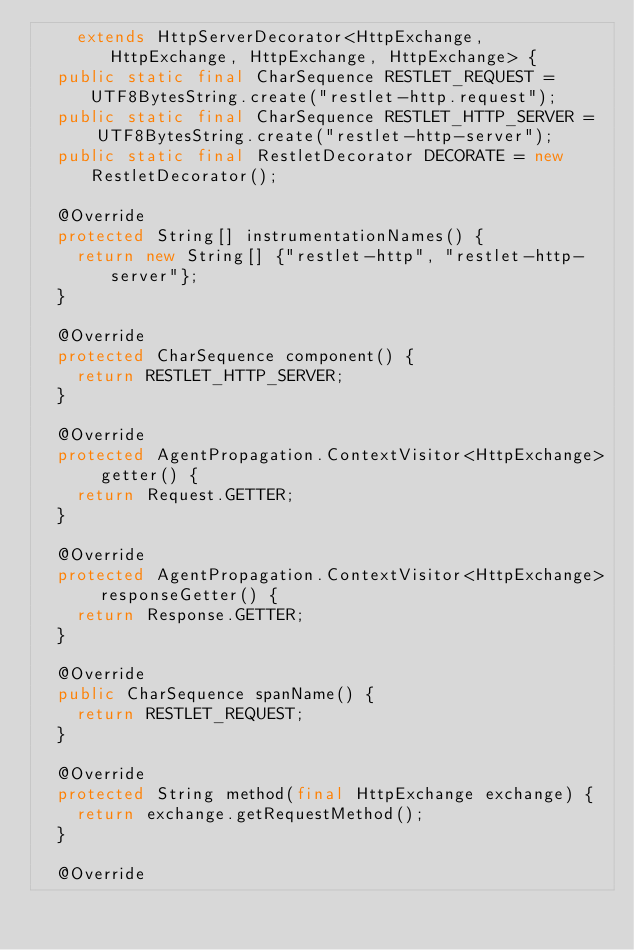Convert code to text. <code><loc_0><loc_0><loc_500><loc_500><_Java_>    extends HttpServerDecorator<HttpExchange, HttpExchange, HttpExchange, HttpExchange> {
  public static final CharSequence RESTLET_REQUEST = UTF8BytesString.create("restlet-http.request");
  public static final CharSequence RESTLET_HTTP_SERVER =
      UTF8BytesString.create("restlet-http-server");
  public static final RestletDecorator DECORATE = new RestletDecorator();

  @Override
  protected String[] instrumentationNames() {
    return new String[] {"restlet-http", "restlet-http-server"};
  }

  @Override
  protected CharSequence component() {
    return RESTLET_HTTP_SERVER;
  }

  @Override
  protected AgentPropagation.ContextVisitor<HttpExchange> getter() {
    return Request.GETTER;
  }

  @Override
  protected AgentPropagation.ContextVisitor<HttpExchange> responseGetter() {
    return Response.GETTER;
  }

  @Override
  public CharSequence spanName() {
    return RESTLET_REQUEST;
  }

  @Override
  protected String method(final HttpExchange exchange) {
    return exchange.getRequestMethod();
  }

  @Override</code> 